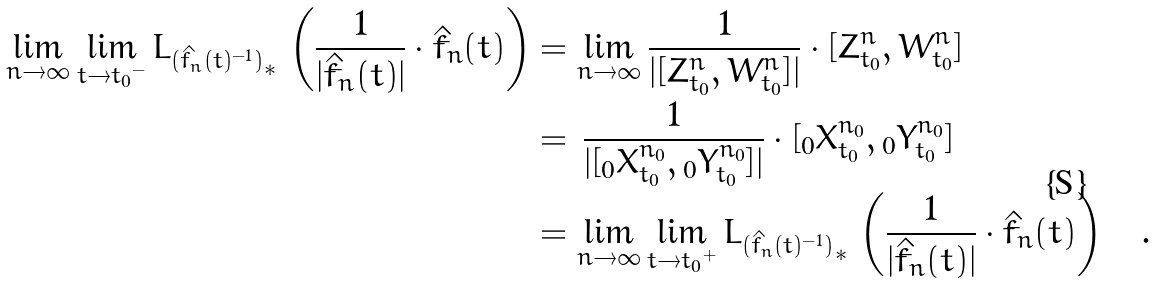<formula> <loc_0><loc_0><loc_500><loc_500>\lim _ { n \rightarrow \infty } \lim _ { t \rightarrow { t _ { 0 } } ^ { - } } { L _ { ( \hat { f } _ { n } ( t ) ^ { - 1 } ) } } _ { * } \, \left ( \frac { 1 } { | \dot { \hat { f } } _ { n } ( t ) | } \cdot \dot { \hat { f } } _ { n } ( t ) \right ) & = \lim _ { n \rightarrow \infty } \frac { 1 } { | [ Z ^ { n } _ { t _ { 0 } } , W ^ { n } _ { t _ { 0 } } ] | } \cdot [ Z ^ { n } _ { t _ { 0 } } , W ^ { n } _ { t _ { 0 } } ] \\ & = \, \frac { 1 } { | [ { _ { 0 } X ^ { n _ { 0 } } _ { t _ { 0 } } } , { _ { 0 } Y ^ { n _ { 0 } } _ { t _ { 0 } } } ] | } \cdot [ { _ { 0 } X ^ { n _ { 0 } } _ { t _ { 0 } } } , { _ { 0 } Y ^ { n _ { 0 } } _ { t _ { 0 } } } ] \\ & = \lim _ { n \rightarrow \infty } \lim _ { t \rightarrow { t _ { 0 } } ^ { + } } { L _ { ( \hat { f } _ { n } ( t ) ^ { - 1 } ) } } _ { * } \, \left ( \frac { 1 } { | \dot { \hat { f } } _ { n } ( t ) | } \cdot \dot { \hat { f } } _ { n } ( t ) \right ) \quad .</formula> 